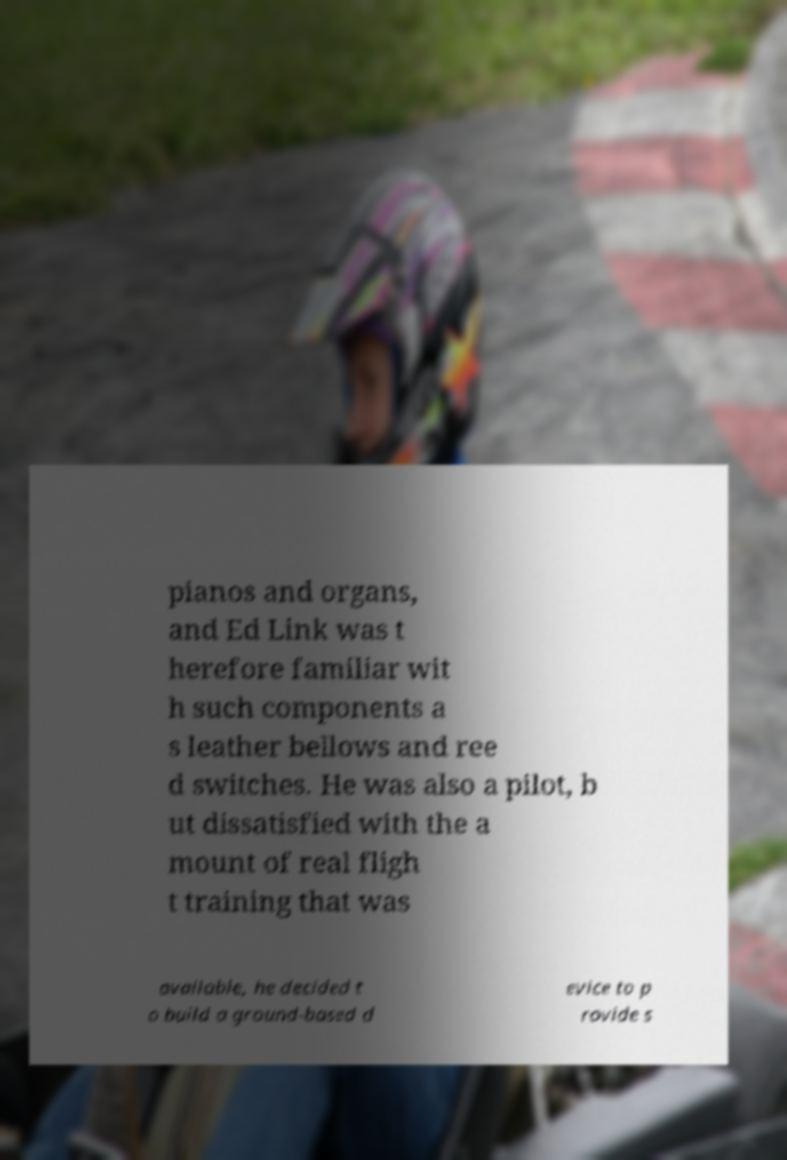Please identify and transcribe the text found in this image. pianos and organs, and Ed Link was t herefore familiar wit h such components a s leather bellows and ree d switches. He was also a pilot, b ut dissatisfied with the a mount of real fligh t training that was available, he decided t o build a ground-based d evice to p rovide s 